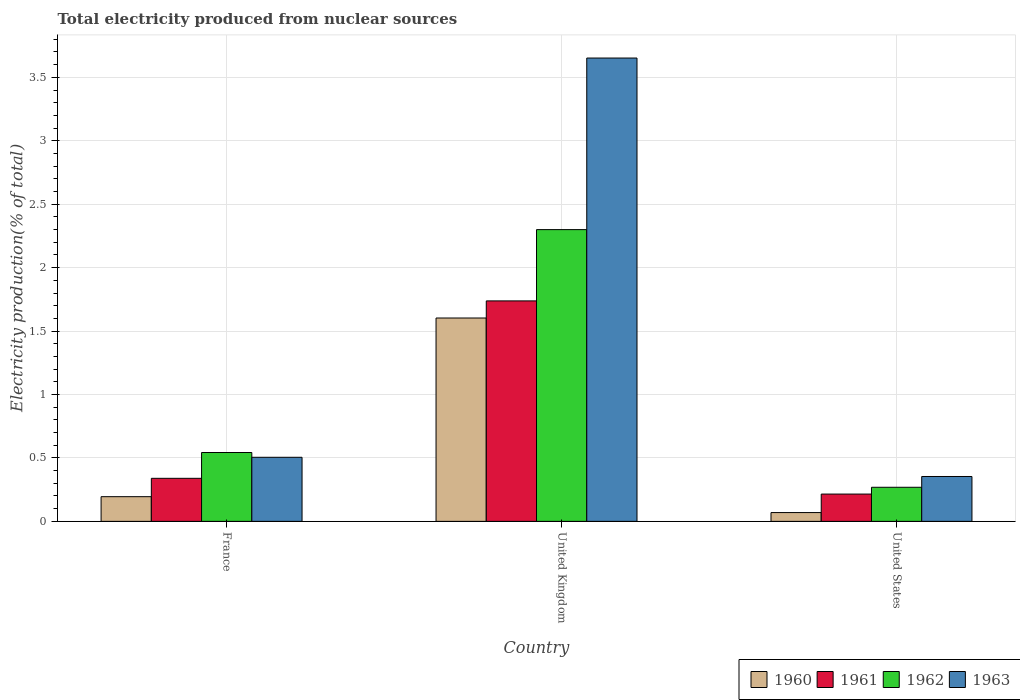How many different coloured bars are there?
Your response must be concise. 4. Are the number of bars per tick equal to the number of legend labels?
Offer a very short reply. Yes. Are the number of bars on each tick of the X-axis equal?
Your response must be concise. Yes. What is the label of the 2nd group of bars from the left?
Your answer should be compact. United Kingdom. In how many cases, is the number of bars for a given country not equal to the number of legend labels?
Your answer should be very brief. 0. What is the total electricity produced in 1960 in United States?
Make the answer very short. 0.07. Across all countries, what is the maximum total electricity produced in 1960?
Provide a short and direct response. 1.6. Across all countries, what is the minimum total electricity produced in 1963?
Provide a succinct answer. 0.35. In which country was the total electricity produced in 1961 maximum?
Offer a terse response. United Kingdom. In which country was the total electricity produced in 1963 minimum?
Make the answer very short. United States. What is the total total electricity produced in 1961 in the graph?
Offer a very short reply. 2.29. What is the difference between the total electricity produced in 1961 in France and that in United States?
Make the answer very short. 0.12. What is the difference between the total electricity produced in 1963 in United Kingdom and the total electricity produced in 1962 in United States?
Your answer should be very brief. 3.38. What is the average total electricity produced in 1963 per country?
Your answer should be compact. 1.5. What is the difference between the total electricity produced of/in 1963 and total electricity produced of/in 1962 in France?
Your answer should be compact. -0.04. What is the ratio of the total electricity produced in 1962 in France to that in United States?
Give a very brief answer. 2.02. Is the total electricity produced in 1963 in France less than that in United Kingdom?
Your answer should be very brief. Yes. What is the difference between the highest and the second highest total electricity produced in 1961?
Make the answer very short. -1.4. What is the difference between the highest and the lowest total electricity produced in 1960?
Provide a short and direct response. 1.53. In how many countries, is the total electricity produced in 1961 greater than the average total electricity produced in 1961 taken over all countries?
Provide a succinct answer. 1. Is it the case that in every country, the sum of the total electricity produced in 1963 and total electricity produced in 1962 is greater than the sum of total electricity produced in 1960 and total electricity produced in 1961?
Ensure brevity in your answer.  No. What does the 3rd bar from the right in United Kingdom represents?
Your answer should be compact. 1961. Is it the case that in every country, the sum of the total electricity produced in 1960 and total electricity produced in 1961 is greater than the total electricity produced in 1963?
Provide a short and direct response. No. How many bars are there?
Offer a very short reply. 12. Are all the bars in the graph horizontal?
Provide a short and direct response. No. Where does the legend appear in the graph?
Provide a short and direct response. Bottom right. How many legend labels are there?
Offer a very short reply. 4. What is the title of the graph?
Offer a very short reply. Total electricity produced from nuclear sources. What is the label or title of the X-axis?
Your response must be concise. Country. What is the label or title of the Y-axis?
Provide a succinct answer. Electricity production(% of total). What is the Electricity production(% of total) of 1960 in France?
Ensure brevity in your answer.  0.19. What is the Electricity production(% of total) of 1961 in France?
Ensure brevity in your answer.  0.34. What is the Electricity production(% of total) of 1962 in France?
Your answer should be compact. 0.54. What is the Electricity production(% of total) of 1963 in France?
Keep it short and to the point. 0.51. What is the Electricity production(% of total) in 1960 in United Kingdom?
Offer a very short reply. 1.6. What is the Electricity production(% of total) in 1961 in United Kingdom?
Offer a very short reply. 1.74. What is the Electricity production(% of total) of 1962 in United Kingdom?
Offer a very short reply. 2.3. What is the Electricity production(% of total) of 1963 in United Kingdom?
Your answer should be compact. 3.65. What is the Electricity production(% of total) of 1960 in United States?
Make the answer very short. 0.07. What is the Electricity production(% of total) in 1961 in United States?
Offer a terse response. 0.22. What is the Electricity production(% of total) in 1962 in United States?
Provide a succinct answer. 0.27. What is the Electricity production(% of total) in 1963 in United States?
Make the answer very short. 0.35. Across all countries, what is the maximum Electricity production(% of total) of 1960?
Make the answer very short. 1.6. Across all countries, what is the maximum Electricity production(% of total) of 1961?
Provide a succinct answer. 1.74. Across all countries, what is the maximum Electricity production(% of total) in 1962?
Ensure brevity in your answer.  2.3. Across all countries, what is the maximum Electricity production(% of total) in 1963?
Offer a very short reply. 3.65. Across all countries, what is the minimum Electricity production(% of total) in 1960?
Make the answer very short. 0.07. Across all countries, what is the minimum Electricity production(% of total) of 1961?
Ensure brevity in your answer.  0.22. Across all countries, what is the minimum Electricity production(% of total) in 1962?
Give a very brief answer. 0.27. Across all countries, what is the minimum Electricity production(% of total) in 1963?
Offer a very short reply. 0.35. What is the total Electricity production(% of total) in 1960 in the graph?
Your answer should be compact. 1.87. What is the total Electricity production(% of total) in 1961 in the graph?
Your answer should be very brief. 2.29. What is the total Electricity production(% of total) of 1962 in the graph?
Your answer should be very brief. 3.11. What is the total Electricity production(% of total) of 1963 in the graph?
Offer a terse response. 4.51. What is the difference between the Electricity production(% of total) of 1960 in France and that in United Kingdom?
Make the answer very short. -1.41. What is the difference between the Electricity production(% of total) of 1961 in France and that in United Kingdom?
Keep it short and to the point. -1.4. What is the difference between the Electricity production(% of total) of 1962 in France and that in United Kingdom?
Provide a short and direct response. -1.76. What is the difference between the Electricity production(% of total) in 1963 in France and that in United Kingdom?
Your answer should be compact. -3.15. What is the difference between the Electricity production(% of total) of 1960 in France and that in United States?
Your answer should be compact. 0.13. What is the difference between the Electricity production(% of total) in 1961 in France and that in United States?
Ensure brevity in your answer.  0.12. What is the difference between the Electricity production(% of total) of 1962 in France and that in United States?
Your response must be concise. 0.27. What is the difference between the Electricity production(% of total) in 1963 in France and that in United States?
Offer a very short reply. 0.15. What is the difference between the Electricity production(% of total) of 1960 in United Kingdom and that in United States?
Offer a very short reply. 1.53. What is the difference between the Electricity production(% of total) in 1961 in United Kingdom and that in United States?
Make the answer very short. 1.52. What is the difference between the Electricity production(% of total) of 1962 in United Kingdom and that in United States?
Give a very brief answer. 2.03. What is the difference between the Electricity production(% of total) in 1963 in United Kingdom and that in United States?
Ensure brevity in your answer.  3.3. What is the difference between the Electricity production(% of total) of 1960 in France and the Electricity production(% of total) of 1961 in United Kingdom?
Your response must be concise. -1.54. What is the difference between the Electricity production(% of total) of 1960 in France and the Electricity production(% of total) of 1962 in United Kingdom?
Provide a succinct answer. -2.11. What is the difference between the Electricity production(% of total) of 1960 in France and the Electricity production(% of total) of 1963 in United Kingdom?
Your answer should be very brief. -3.46. What is the difference between the Electricity production(% of total) in 1961 in France and the Electricity production(% of total) in 1962 in United Kingdom?
Your answer should be very brief. -1.96. What is the difference between the Electricity production(% of total) in 1961 in France and the Electricity production(% of total) in 1963 in United Kingdom?
Provide a short and direct response. -3.31. What is the difference between the Electricity production(% of total) of 1962 in France and the Electricity production(% of total) of 1963 in United Kingdom?
Your answer should be very brief. -3.11. What is the difference between the Electricity production(% of total) of 1960 in France and the Electricity production(% of total) of 1961 in United States?
Provide a short and direct response. -0.02. What is the difference between the Electricity production(% of total) in 1960 in France and the Electricity production(% of total) in 1962 in United States?
Provide a short and direct response. -0.07. What is the difference between the Electricity production(% of total) of 1960 in France and the Electricity production(% of total) of 1963 in United States?
Give a very brief answer. -0.16. What is the difference between the Electricity production(% of total) of 1961 in France and the Electricity production(% of total) of 1962 in United States?
Provide a succinct answer. 0.07. What is the difference between the Electricity production(% of total) in 1961 in France and the Electricity production(% of total) in 1963 in United States?
Provide a succinct answer. -0.01. What is the difference between the Electricity production(% of total) in 1962 in France and the Electricity production(% of total) in 1963 in United States?
Offer a very short reply. 0.19. What is the difference between the Electricity production(% of total) in 1960 in United Kingdom and the Electricity production(% of total) in 1961 in United States?
Ensure brevity in your answer.  1.39. What is the difference between the Electricity production(% of total) of 1960 in United Kingdom and the Electricity production(% of total) of 1962 in United States?
Ensure brevity in your answer.  1.33. What is the difference between the Electricity production(% of total) of 1960 in United Kingdom and the Electricity production(% of total) of 1963 in United States?
Provide a succinct answer. 1.25. What is the difference between the Electricity production(% of total) of 1961 in United Kingdom and the Electricity production(% of total) of 1962 in United States?
Give a very brief answer. 1.47. What is the difference between the Electricity production(% of total) of 1961 in United Kingdom and the Electricity production(% of total) of 1963 in United States?
Your answer should be compact. 1.38. What is the difference between the Electricity production(% of total) in 1962 in United Kingdom and the Electricity production(% of total) in 1963 in United States?
Provide a short and direct response. 1.95. What is the average Electricity production(% of total) in 1960 per country?
Your response must be concise. 0.62. What is the average Electricity production(% of total) in 1961 per country?
Your response must be concise. 0.76. What is the average Electricity production(% of total) in 1962 per country?
Your answer should be very brief. 1.04. What is the average Electricity production(% of total) in 1963 per country?
Give a very brief answer. 1.5. What is the difference between the Electricity production(% of total) in 1960 and Electricity production(% of total) in 1961 in France?
Provide a succinct answer. -0.14. What is the difference between the Electricity production(% of total) in 1960 and Electricity production(% of total) in 1962 in France?
Your answer should be compact. -0.35. What is the difference between the Electricity production(% of total) of 1960 and Electricity production(% of total) of 1963 in France?
Ensure brevity in your answer.  -0.31. What is the difference between the Electricity production(% of total) in 1961 and Electricity production(% of total) in 1962 in France?
Provide a short and direct response. -0.2. What is the difference between the Electricity production(% of total) of 1961 and Electricity production(% of total) of 1963 in France?
Provide a succinct answer. -0.17. What is the difference between the Electricity production(% of total) in 1962 and Electricity production(% of total) in 1963 in France?
Offer a terse response. 0.04. What is the difference between the Electricity production(% of total) in 1960 and Electricity production(% of total) in 1961 in United Kingdom?
Provide a short and direct response. -0.13. What is the difference between the Electricity production(% of total) of 1960 and Electricity production(% of total) of 1962 in United Kingdom?
Make the answer very short. -0.7. What is the difference between the Electricity production(% of total) in 1960 and Electricity production(% of total) in 1963 in United Kingdom?
Your response must be concise. -2.05. What is the difference between the Electricity production(% of total) in 1961 and Electricity production(% of total) in 1962 in United Kingdom?
Keep it short and to the point. -0.56. What is the difference between the Electricity production(% of total) in 1961 and Electricity production(% of total) in 1963 in United Kingdom?
Your answer should be compact. -1.91. What is the difference between the Electricity production(% of total) of 1962 and Electricity production(% of total) of 1963 in United Kingdom?
Keep it short and to the point. -1.35. What is the difference between the Electricity production(% of total) in 1960 and Electricity production(% of total) in 1961 in United States?
Provide a succinct answer. -0.15. What is the difference between the Electricity production(% of total) in 1960 and Electricity production(% of total) in 1962 in United States?
Provide a short and direct response. -0.2. What is the difference between the Electricity production(% of total) of 1960 and Electricity production(% of total) of 1963 in United States?
Keep it short and to the point. -0.28. What is the difference between the Electricity production(% of total) in 1961 and Electricity production(% of total) in 1962 in United States?
Keep it short and to the point. -0.05. What is the difference between the Electricity production(% of total) in 1961 and Electricity production(% of total) in 1963 in United States?
Offer a terse response. -0.14. What is the difference between the Electricity production(% of total) of 1962 and Electricity production(% of total) of 1963 in United States?
Keep it short and to the point. -0.09. What is the ratio of the Electricity production(% of total) of 1960 in France to that in United Kingdom?
Give a very brief answer. 0.12. What is the ratio of the Electricity production(% of total) in 1961 in France to that in United Kingdom?
Provide a short and direct response. 0.2. What is the ratio of the Electricity production(% of total) of 1962 in France to that in United Kingdom?
Provide a short and direct response. 0.24. What is the ratio of the Electricity production(% of total) of 1963 in France to that in United Kingdom?
Your answer should be very brief. 0.14. What is the ratio of the Electricity production(% of total) in 1960 in France to that in United States?
Your answer should be very brief. 2.81. What is the ratio of the Electricity production(% of total) of 1961 in France to that in United States?
Your response must be concise. 1.58. What is the ratio of the Electricity production(% of total) of 1962 in France to that in United States?
Offer a very short reply. 2.02. What is the ratio of the Electricity production(% of total) in 1963 in France to that in United States?
Ensure brevity in your answer.  1.43. What is the ratio of the Electricity production(% of total) of 1960 in United Kingdom to that in United States?
Give a very brief answer. 23.14. What is the ratio of the Electricity production(% of total) of 1961 in United Kingdom to that in United States?
Provide a succinct answer. 8.08. What is the ratio of the Electricity production(% of total) of 1962 in United Kingdom to that in United States?
Your response must be concise. 8.56. What is the ratio of the Electricity production(% of total) of 1963 in United Kingdom to that in United States?
Provide a succinct answer. 10.32. What is the difference between the highest and the second highest Electricity production(% of total) in 1960?
Ensure brevity in your answer.  1.41. What is the difference between the highest and the second highest Electricity production(% of total) in 1961?
Provide a succinct answer. 1.4. What is the difference between the highest and the second highest Electricity production(% of total) of 1962?
Ensure brevity in your answer.  1.76. What is the difference between the highest and the second highest Electricity production(% of total) in 1963?
Give a very brief answer. 3.15. What is the difference between the highest and the lowest Electricity production(% of total) of 1960?
Ensure brevity in your answer.  1.53. What is the difference between the highest and the lowest Electricity production(% of total) of 1961?
Your answer should be compact. 1.52. What is the difference between the highest and the lowest Electricity production(% of total) of 1962?
Provide a succinct answer. 2.03. What is the difference between the highest and the lowest Electricity production(% of total) in 1963?
Your response must be concise. 3.3. 